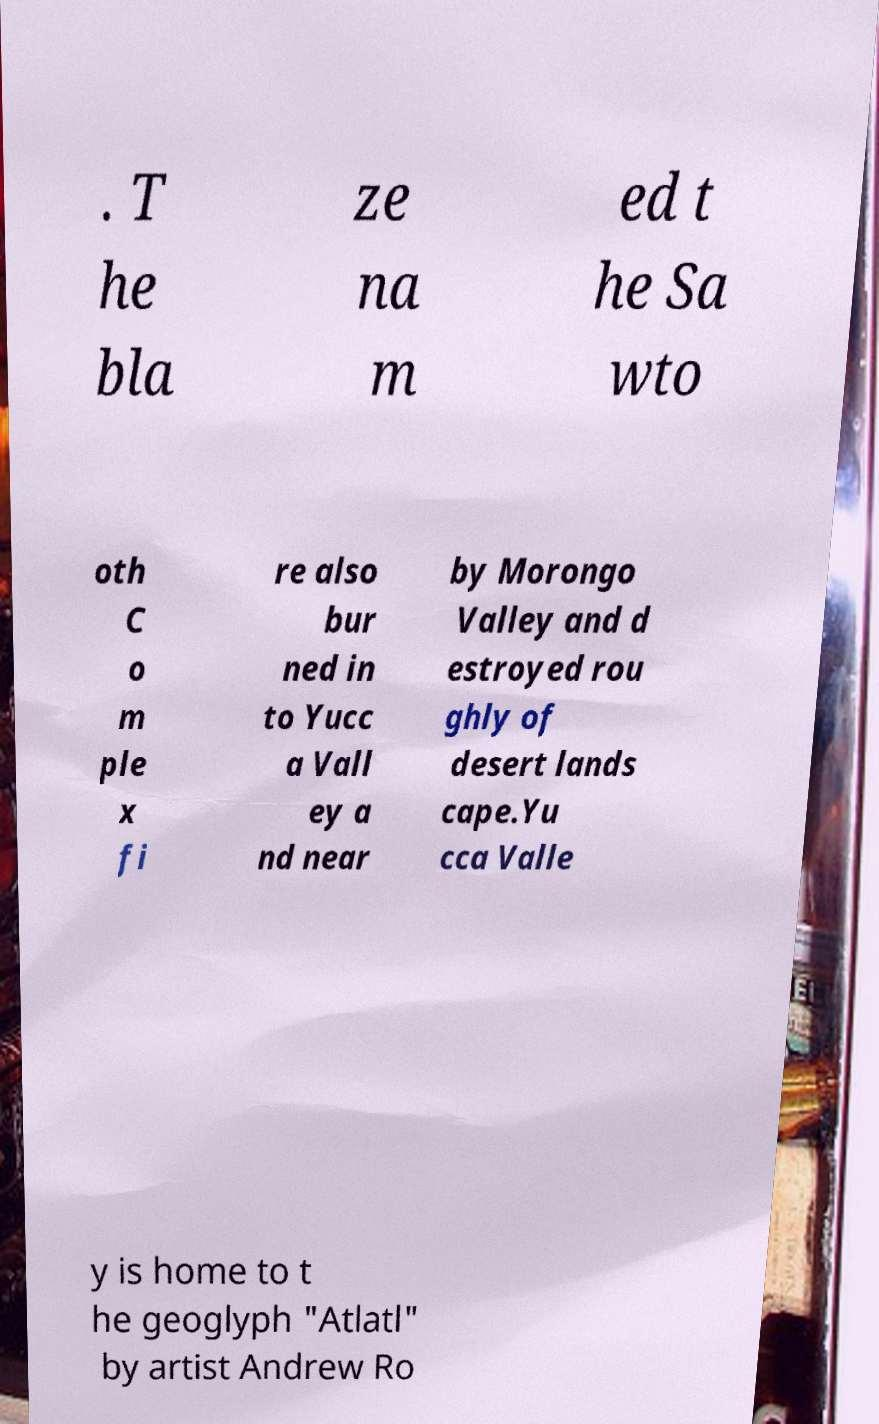Can you accurately transcribe the text from the provided image for me? . T he bla ze na m ed t he Sa wto oth C o m ple x fi re also bur ned in to Yucc a Vall ey a nd near by Morongo Valley and d estroyed rou ghly of desert lands cape.Yu cca Valle y is home to t he geoglyph "Atlatl" by artist Andrew Ro 